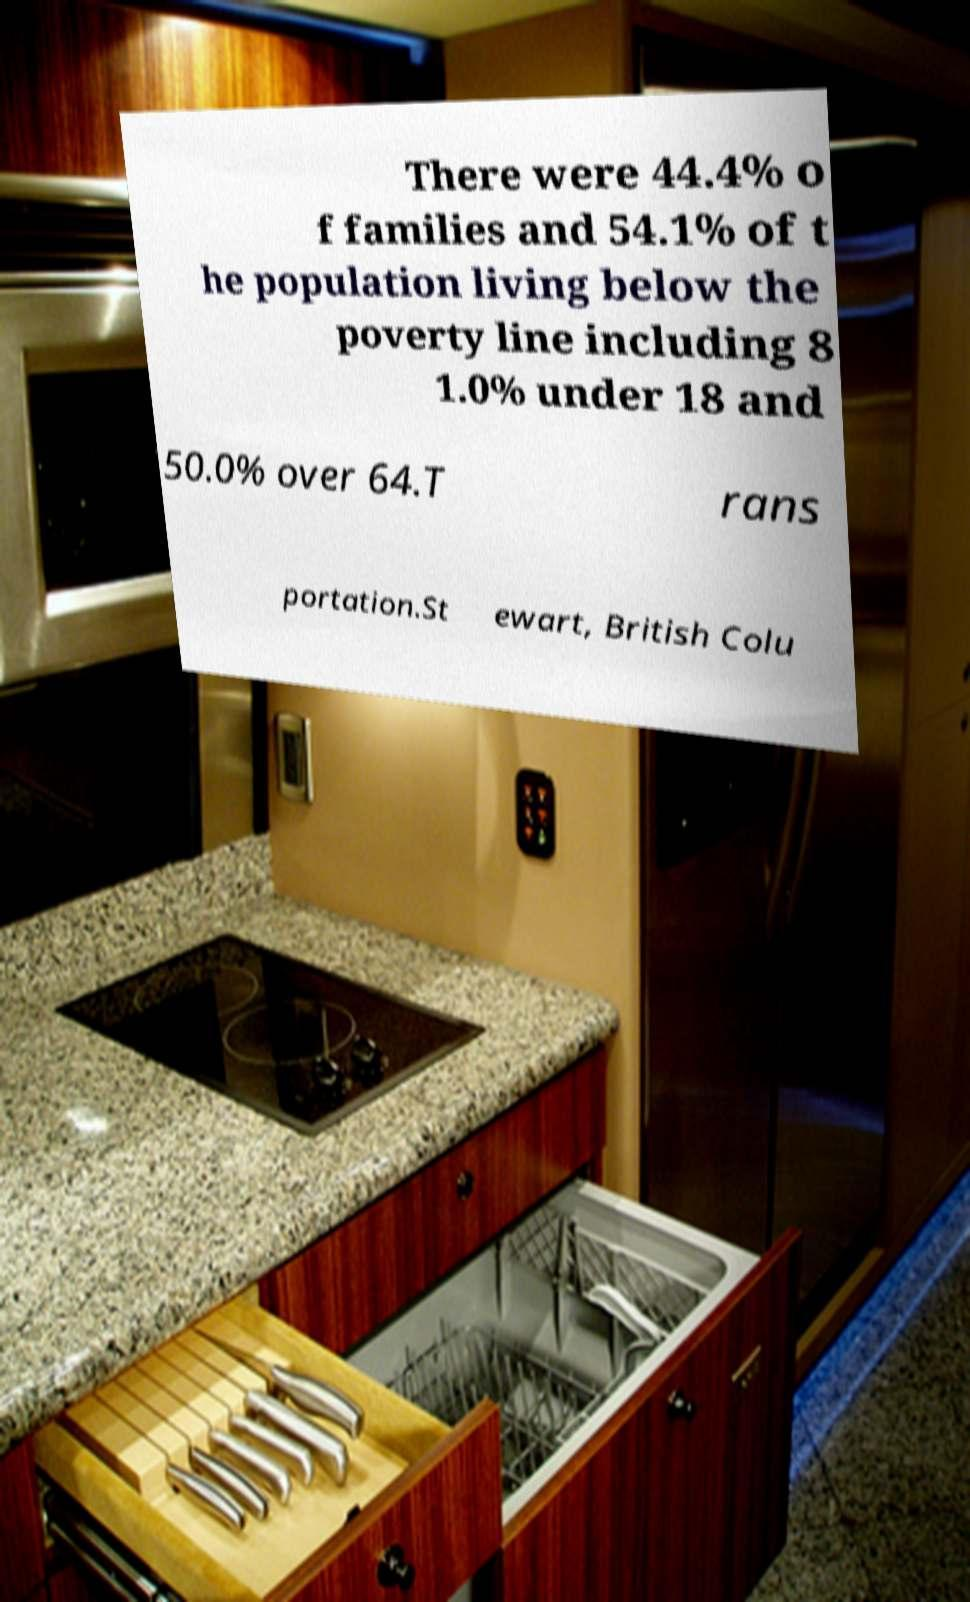Could you extract and type out the text from this image? There were 44.4% o f families and 54.1% of t he population living below the poverty line including 8 1.0% under 18 and 50.0% over 64.T rans portation.St ewart, British Colu 